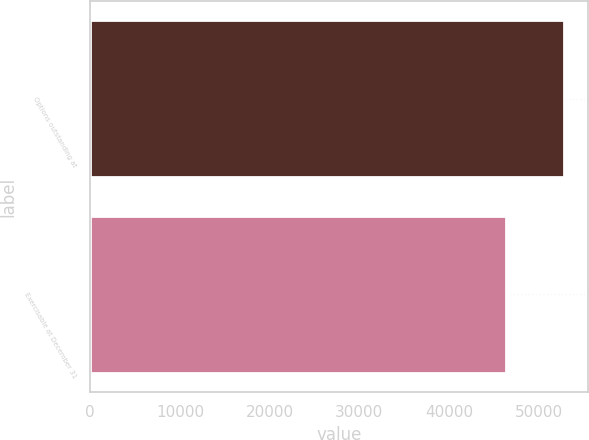<chart> <loc_0><loc_0><loc_500><loc_500><bar_chart><fcel>Options outstanding at<fcel>Exercisable at December 31<nl><fcel>52850<fcel>46352<nl></chart> 